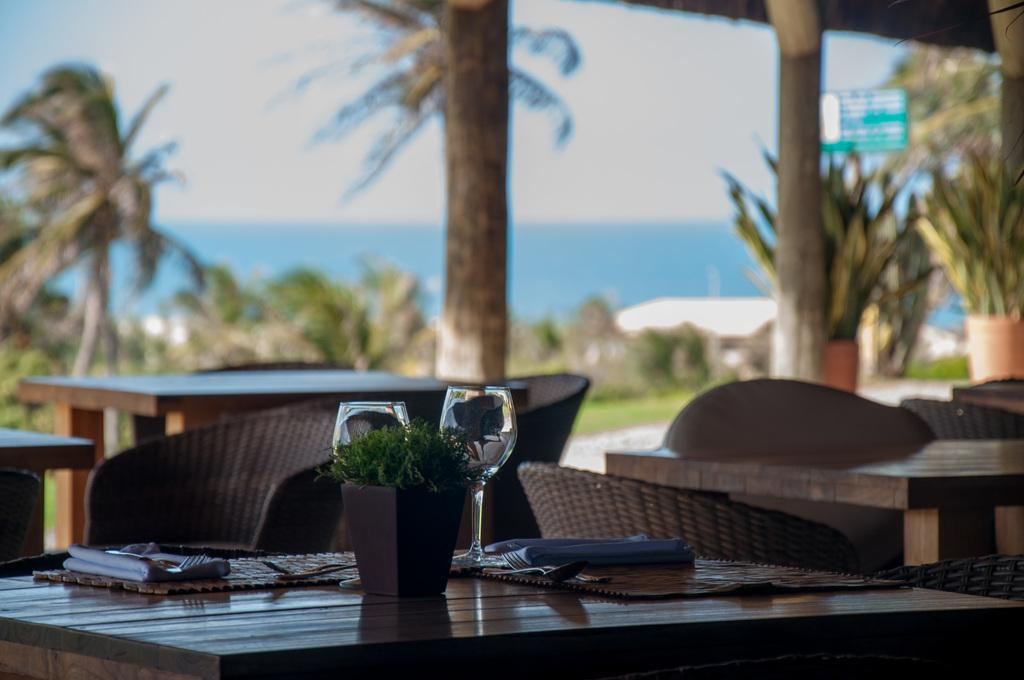What type of table is in the image? There is a wooden table in the image. How many glasses are on the table? There are 2 glasses on the table. What else is present on the table besides the glasses? Napkins and spoons are visible on the table. What can be seen behind the table in the image? There are trees behind the table. What is visible in the image besides the table and its contents? Water is visible in the image. What type of patch is sewn onto the tablecloth in the image? There is no tablecloth or patch present in the image; it features a wooden table with glasses, napkins, and spoons on it. 